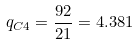<formula> <loc_0><loc_0><loc_500><loc_500>q _ { C 4 } = \frac { 9 2 } { 2 1 } = 4 . 3 8 1</formula> 